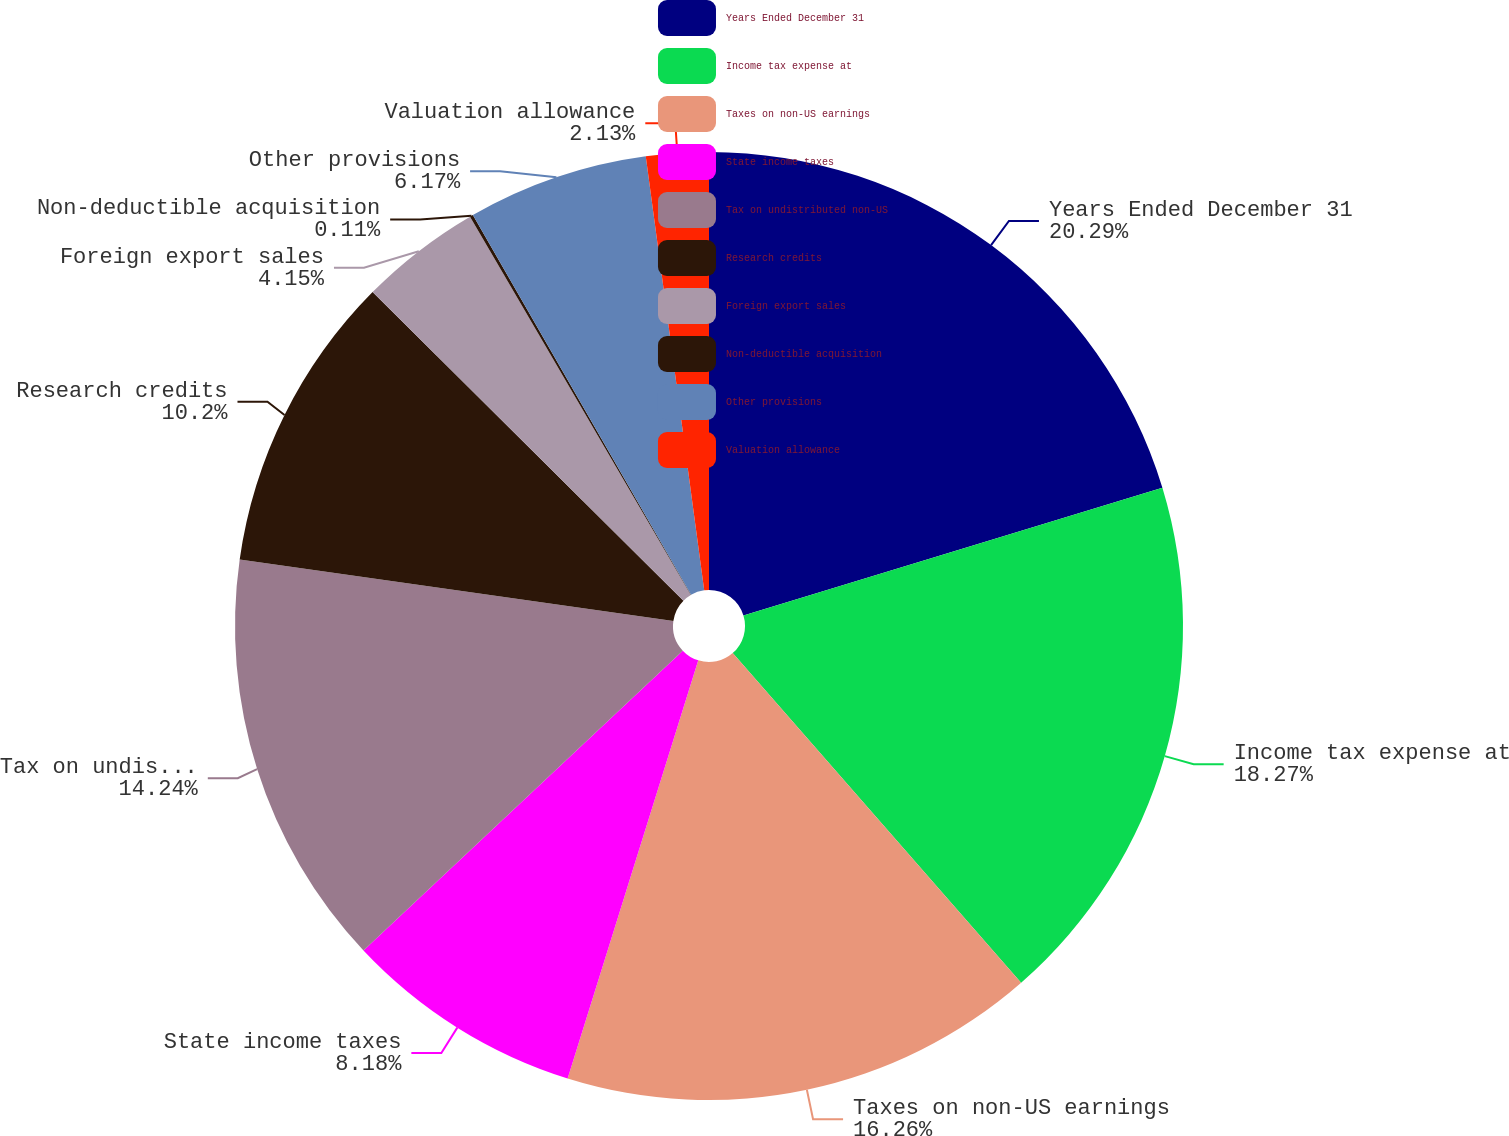<chart> <loc_0><loc_0><loc_500><loc_500><pie_chart><fcel>Years Ended December 31<fcel>Income tax expense at<fcel>Taxes on non-US earnings<fcel>State income taxes<fcel>Tax on undistributed non-US<fcel>Research credits<fcel>Foreign export sales<fcel>Non-deductible acquisition<fcel>Other provisions<fcel>Valuation allowance<nl><fcel>20.29%<fcel>18.27%<fcel>16.26%<fcel>8.18%<fcel>14.24%<fcel>10.2%<fcel>4.15%<fcel>0.11%<fcel>6.17%<fcel>2.13%<nl></chart> 